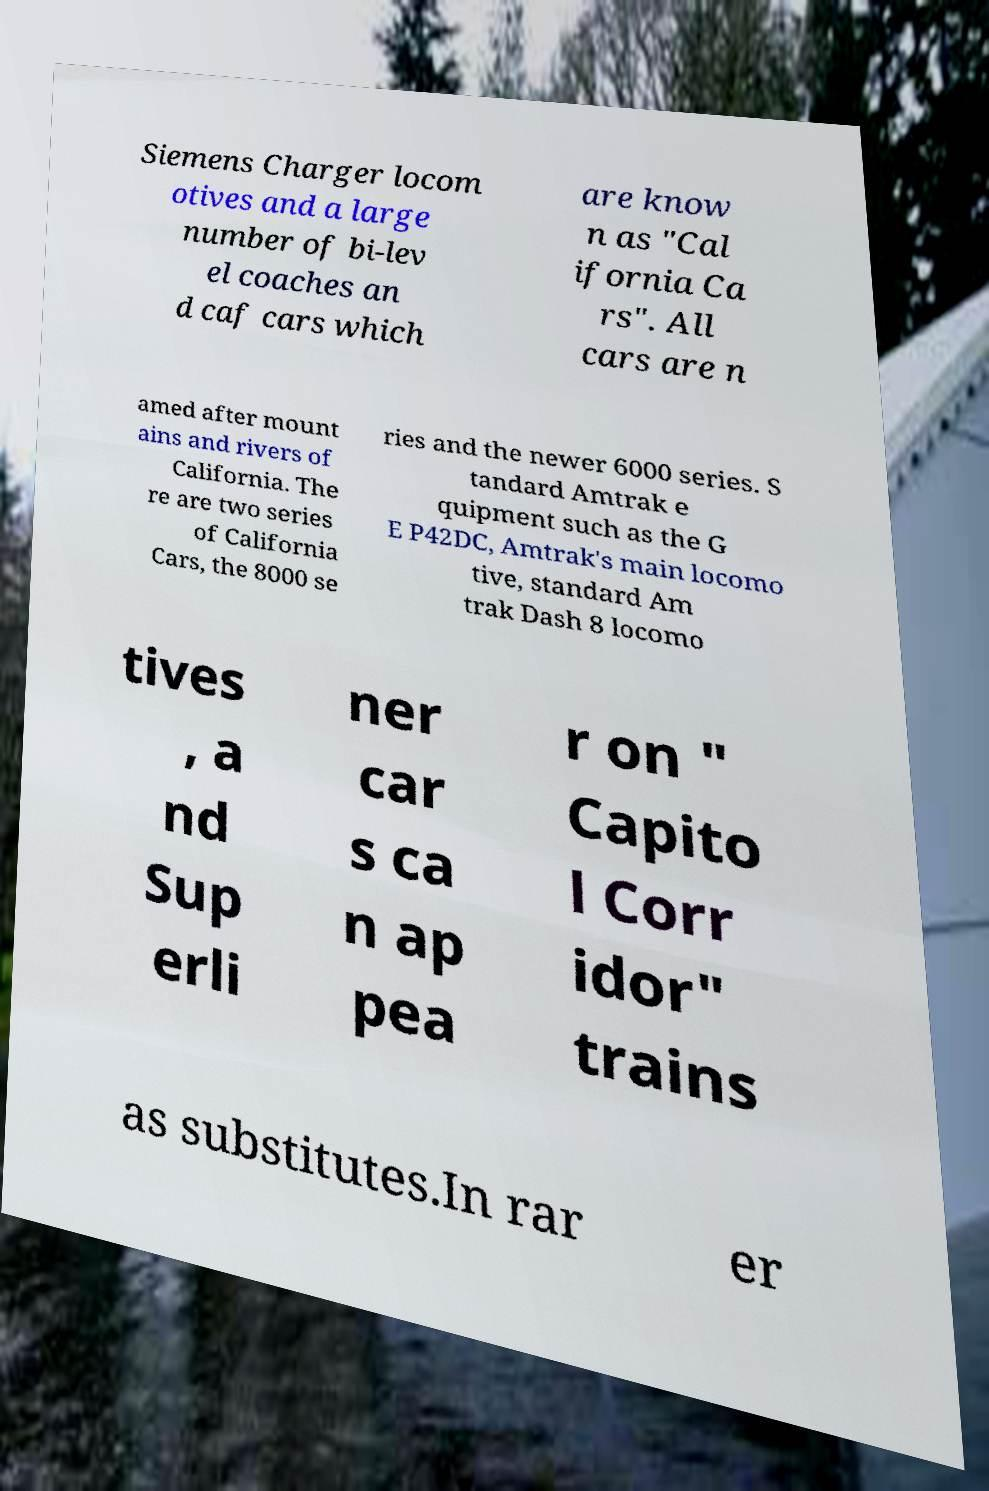Can you accurately transcribe the text from the provided image for me? Siemens Charger locom otives and a large number of bi-lev el coaches an d caf cars which are know n as "Cal ifornia Ca rs". All cars are n amed after mount ains and rivers of California. The re are two series of California Cars, the 8000 se ries and the newer 6000 series. S tandard Amtrak e quipment such as the G E P42DC, Amtrak's main locomo tive, standard Am trak Dash 8 locomo tives , a nd Sup erli ner car s ca n ap pea r on " Capito l Corr idor" trains as substitutes.In rar er 